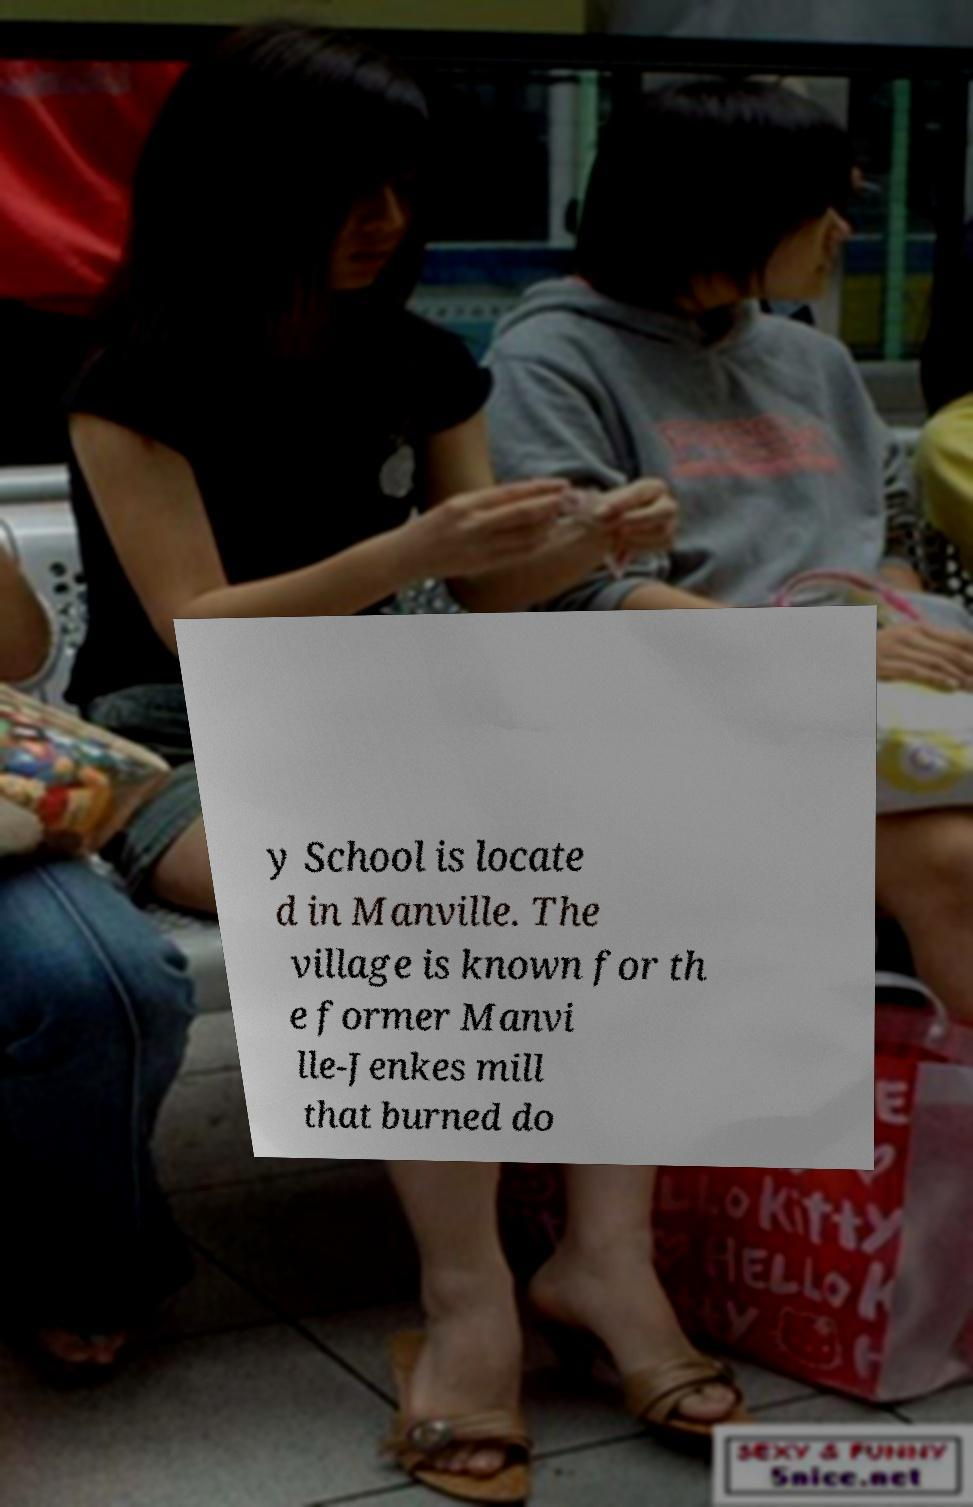I need the written content from this picture converted into text. Can you do that? y School is locate d in Manville. The village is known for th e former Manvi lle-Jenkes mill that burned do 